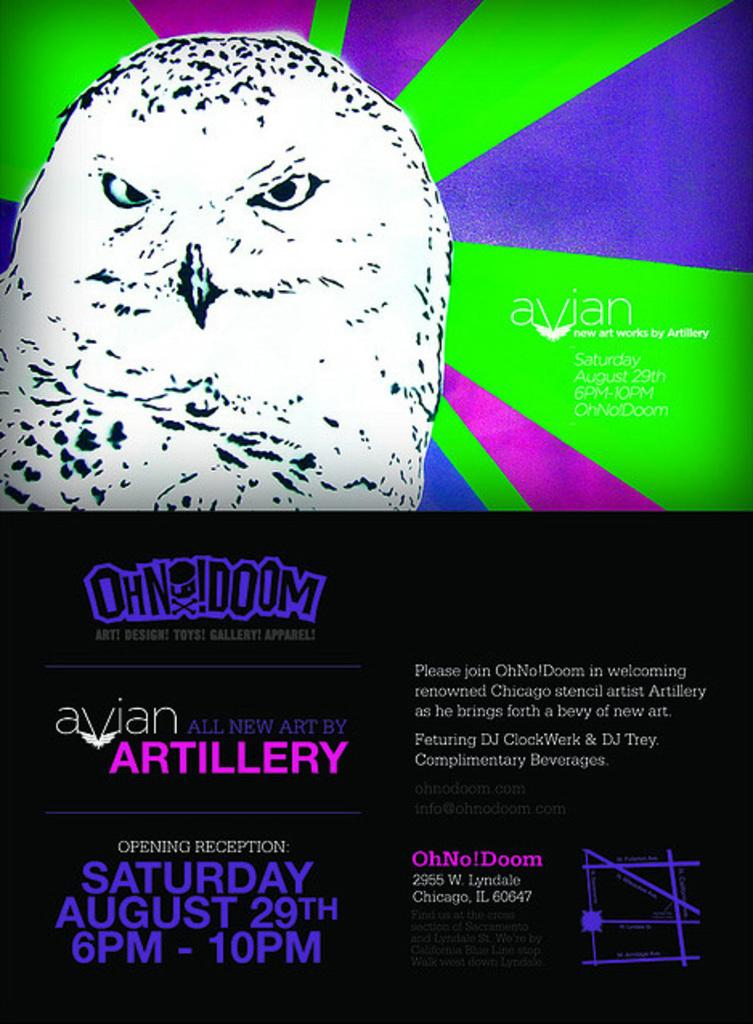What is featured on the poster in the image? There is a poster in the image, and it contains a picture of an owl. What else can be found on the poster besides the owl? The poster contains text. Can you hear the grandfather's voice coming from the owl in the image? There is no mention of a grandfather or any sound in the image, so it is not possible to answer that question. 